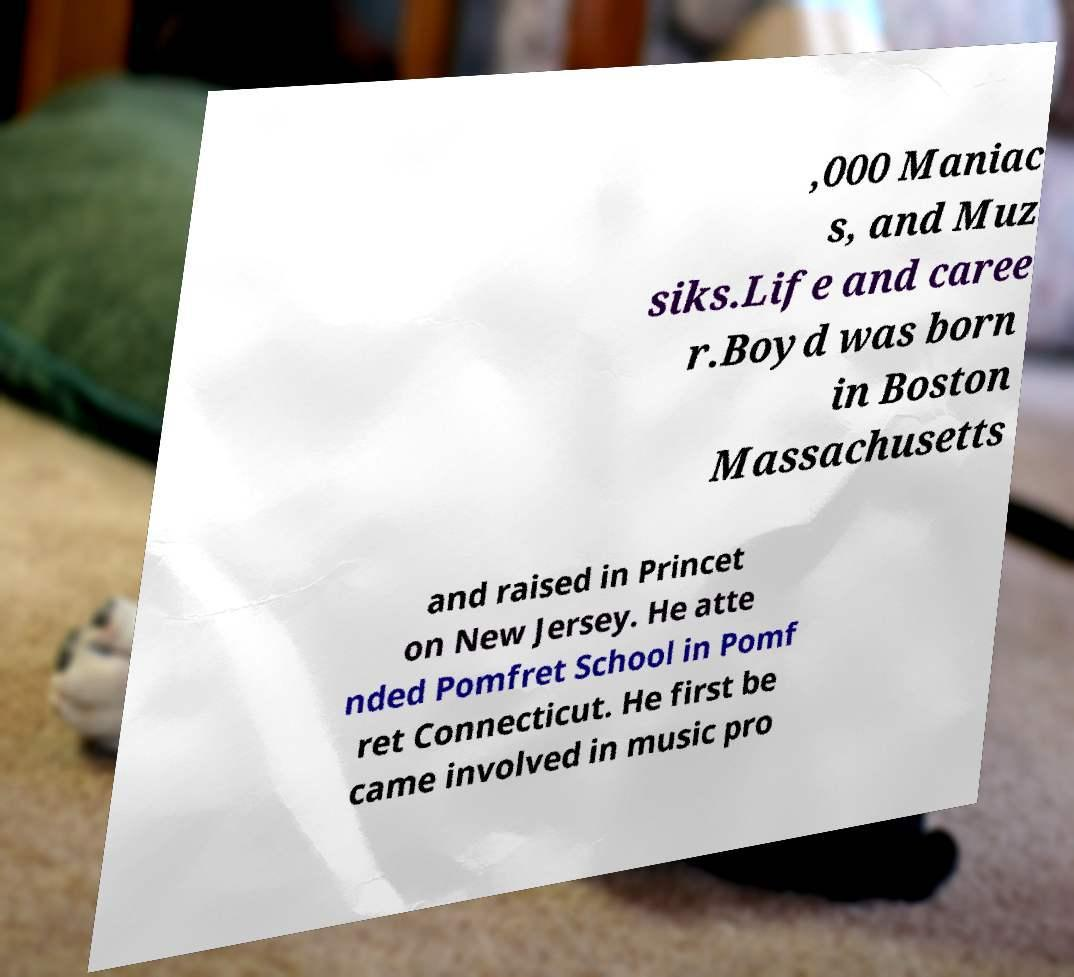Could you extract and type out the text from this image? ,000 Maniac s, and Muz siks.Life and caree r.Boyd was born in Boston Massachusetts and raised in Princet on New Jersey. He atte nded Pomfret School in Pomf ret Connecticut. He first be came involved in music pro 